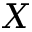Convert formula to latex. <formula><loc_0><loc_0><loc_500><loc_500>X</formula> 